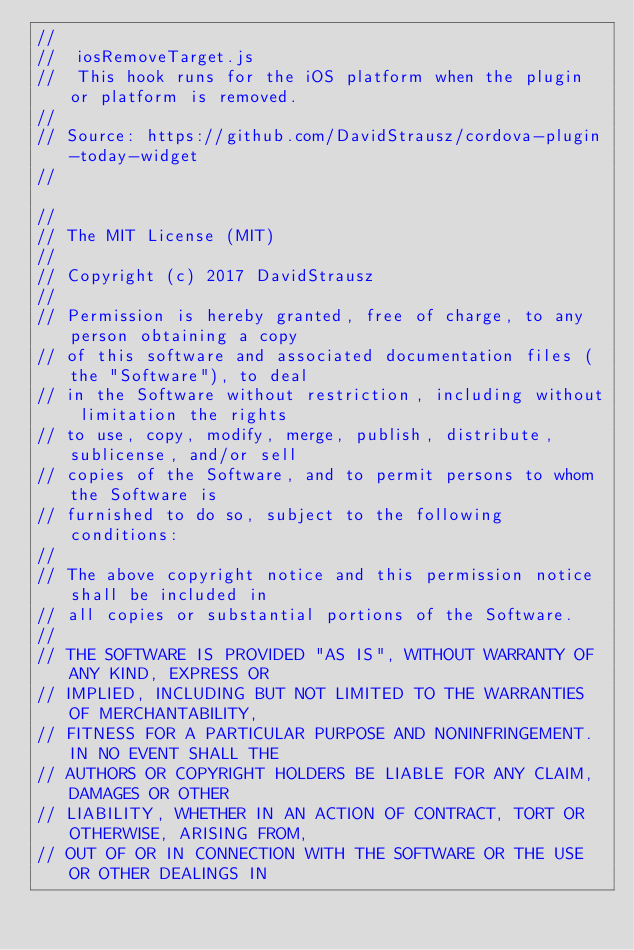Convert code to text. <code><loc_0><loc_0><loc_500><loc_500><_JavaScript_>//
//  iosRemoveTarget.js
//  This hook runs for the iOS platform when the plugin or platform is removed.
//
// Source: https://github.com/DavidStrausz/cordova-plugin-today-widget
//

//
// The MIT License (MIT)
//
// Copyright (c) 2017 DavidStrausz
//
// Permission is hereby granted, free of charge, to any person obtaining a copy
// of this software and associated documentation files (the "Software"), to deal
// in the Software without restriction, including without limitation the rights
// to use, copy, modify, merge, publish, distribute, sublicense, and/or sell
// copies of the Software, and to permit persons to whom the Software is
// furnished to do so, subject to the following conditions:
//
// The above copyright notice and this permission notice shall be included in
// all copies or substantial portions of the Software.
//
// THE SOFTWARE IS PROVIDED "AS IS", WITHOUT WARRANTY OF ANY KIND, EXPRESS OR
// IMPLIED, INCLUDING BUT NOT LIMITED TO THE WARRANTIES OF MERCHANTABILITY,
// FITNESS FOR A PARTICULAR PURPOSE AND NONINFRINGEMENT. IN NO EVENT SHALL THE
// AUTHORS OR COPYRIGHT HOLDERS BE LIABLE FOR ANY CLAIM, DAMAGES OR OTHER
// LIABILITY, WHETHER IN AN ACTION OF CONTRACT, TORT OR OTHERWISE, ARISING FROM,
// OUT OF OR IN CONNECTION WITH THE SOFTWARE OR THE USE OR OTHER DEALINGS IN</code> 